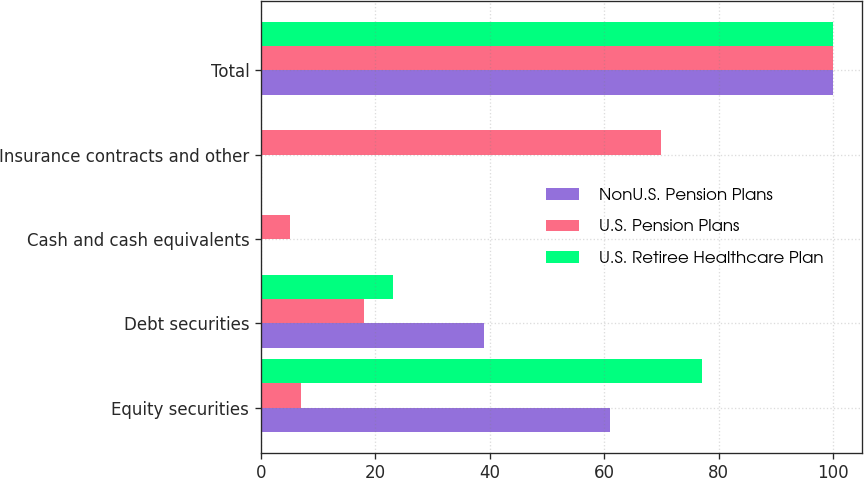Convert chart. <chart><loc_0><loc_0><loc_500><loc_500><stacked_bar_chart><ecel><fcel>Equity securities<fcel>Debt securities<fcel>Cash and cash equivalents<fcel>Insurance contracts and other<fcel>Total<nl><fcel>NonU.S. Pension Plans<fcel>61<fcel>39<fcel>0<fcel>0<fcel>100<nl><fcel>U.S. Pension Plans<fcel>7<fcel>18<fcel>5<fcel>70<fcel>100<nl><fcel>U.S. Retiree Healthcare Plan<fcel>77<fcel>23<fcel>0<fcel>0<fcel>100<nl></chart> 